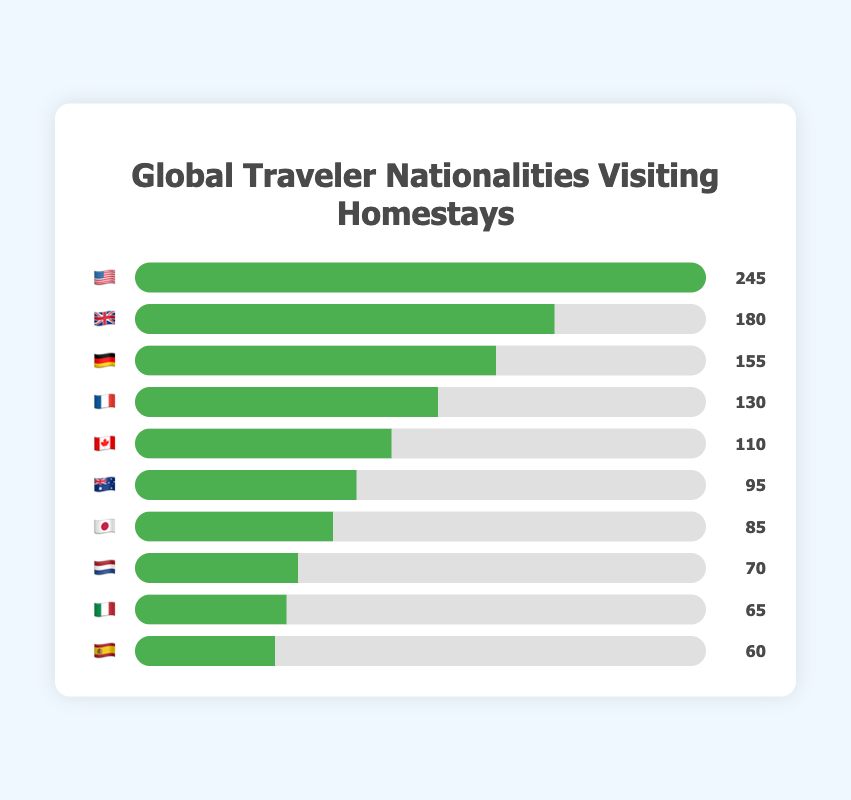What is the nationality of the travelers with the highest number of visitors? The chart shows different nationalities represented by country flag emojis and their corresponding visitor numbers. The nationality with the highest visitor count is represented by the 🇺🇸 flag with 245 visitors.
Answer: 🇺🇸 What is the total number of visitors from 🇬🇧 and 🇫🇷? We need to sum the visitors from the United Kingdom (🇬🇧) and France (🇫🇷). According to the chart: 180 (🇬🇧) + 130 (🇫🇷) = 310.
Answer: 310 How many more visitors are there from 🇺🇸 compared to 🇦🇺? Subtract the number of 🇦🇺 visitors from the number of 🇺🇸 visitors. 245 (🇺🇸) - 95 (🇦🇺) = 150.
Answer: 150 Which countries have fewer than 100 visitors? The countries with fewer than 100 visitors are those with a visitor number below 100 in the chart. These countries are 🇦🇺 (95), 🇯🇵 (85), 🇳🇱 (70), 🇮🇹 (65), and 🇪🇸 (60).
Answer: 🇦🇺, 🇯🇵, 🇳🇱, 🇮🇹, 🇪🇸 What is the average number of visitors from all countries combined? First, sum the total number of visitors, then divide by the number of countries. The total is 245 + 180 + 155 + 130 + 110 + 95 + 85 + 70 + 65 + 60 = 1195. There are 10 countries, so the average is 1195 / 10 = 119.5.
Answer: 119.5 How does the number of visitors from 🇯🇵 compare to those from 🇨🇦 and 🇫🇷 combined? We need to compare the number of visitors from 🇯🇵 with the combined number from 🇨🇦 and 🇫🇷. First, sum the visitors from 🇨🇦 and 🇫🇷: 110 + 130 = 240. Then compare it to 🇯🇵 which has 85 visitors. 240 (🇨🇦 and 🇫🇷 combined) is greater than 85 (🇯🇵).
Answer: Fewer What percentage of total visitors are from 🇩🇪? First, calculate the total number of visitors, which is 1195. The number of 🇩🇪 visitors is 155. The percentage is (155 / 1195) * 100%. (155 / 1195) * 100% ≈ 12.97%.
Answer: ~12.97% Which two countries combined have close to 200 visitors? We need to find two countries whose combined visitor numbers are close to 200. 🇫🇷 has 130 visitors and 🇨🇦 has 110 visitors. Their combined number is 130 + 110 = 240, which is reasonably close to 200. Alternatively, 🇨🇦 with 110 and 🇦🇺 with 95 combined is 110 + 95 = 205, which is also close to 200.
Answer: 🇨🇦 and 🇦🇺 How many countries have more visitors than 🇯🇵? We count the countries with visitor numbers higher than 85 (the number of Japanese visitors). These countries are 🇺🇸 (245), 🇬🇧 (180), 🇩🇪 (155), 🇫🇷 (130), and 🇨🇦 (110). There are 5 such countries.
Answer: 5 What is the difference in the number of visitors between the countries with the second and fourth highest visitor counts? The second highest visitor count is from 🇬🇧 with 180 visitors, and the fourth highest is from 🇫🇷 with 130 visitors. The difference is 180 - 130 = 50.
Answer: 50 